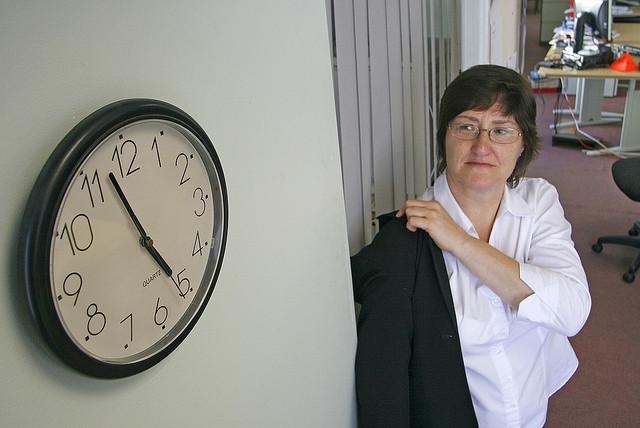Why is she getting ready to go and watching the clock at the same time?
Quick response, please. Clocking out. Is it possible that she is using a cell phone?
Answer briefly. No. What time is it?
Keep it brief. 4:57. What room is the picture likely taken?
Short answer required. Office. Is the woman in an office?
Be succinct. Yes. 